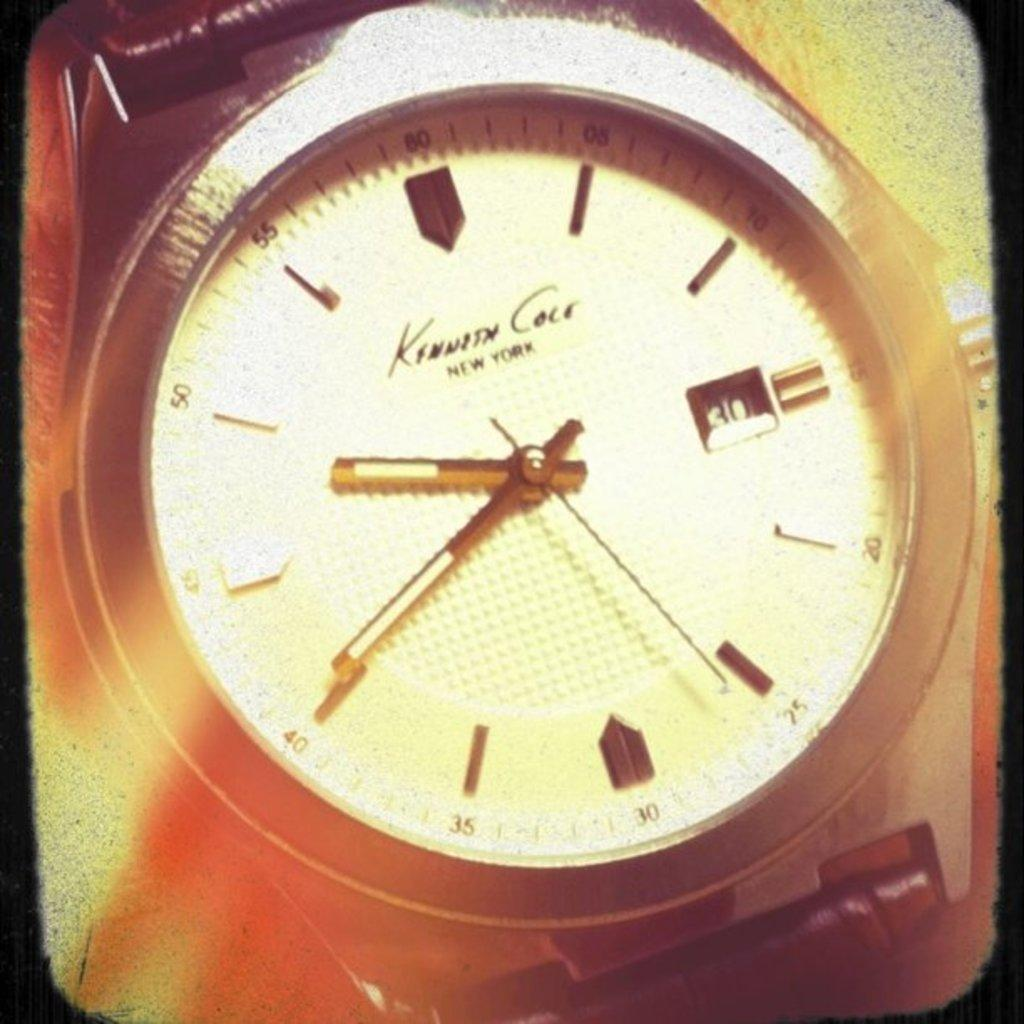What object is the main focus of the image? There is a wrist watch in the image. What can be observed about the background of the image? The background of the image is yellow and orange in color. What type of notebook is being used to set an alarm in the image? There is no notebook or alarm present in the image; it only features a wrist watch. What force is being applied to the wrist watch in the image? There is no force being applied to the wrist watch in the image; it is simply displayed. 